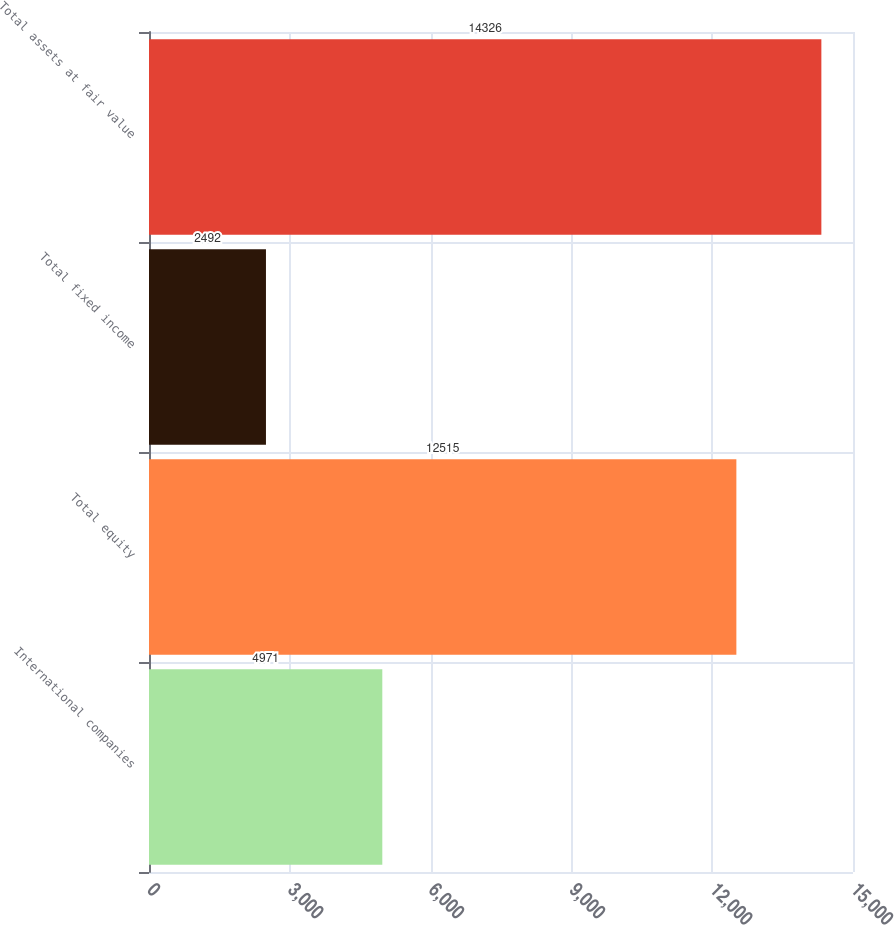<chart> <loc_0><loc_0><loc_500><loc_500><bar_chart><fcel>International companies<fcel>Total equity<fcel>Total fixed income<fcel>Total assets at fair value<nl><fcel>4971<fcel>12515<fcel>2492<fcel>14326<nl></chart> 